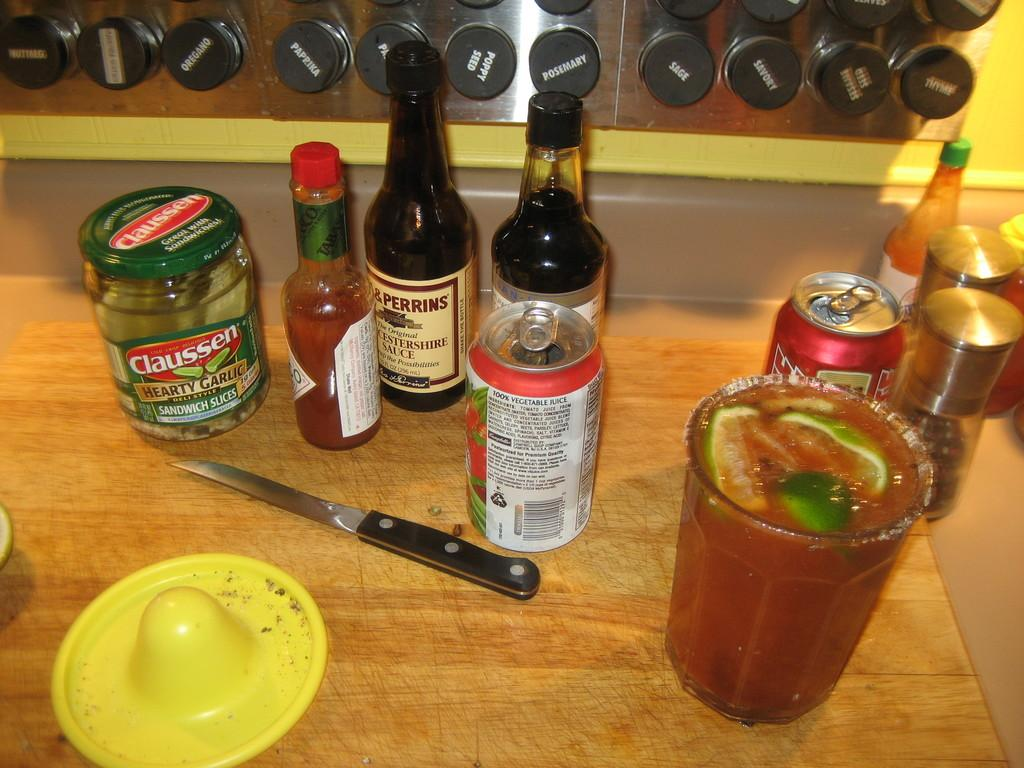<image>
Relay a brief, clear account of the picture shown. Lots of condiments and different bottles on a table, containing worchestershire sauce, tabasco, and a soda can. 